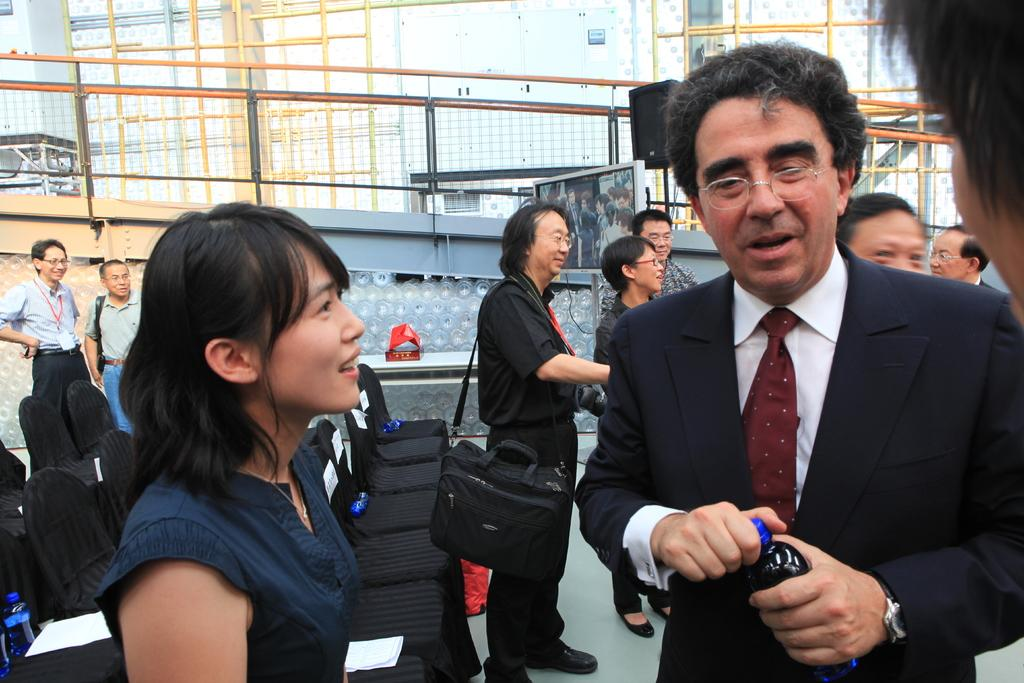Who or what can be seen in the image? There are people in the image. What are the people sitting on in the image? There are chairs in the image. What can be seen in the distance in the image? There are buildings in the background of the image. What objects are present that resemble long, thin bars? There are rods in the image or background. What is the flat, rectangular object in the image? There is a board in the image. What type of grain is being harvested in the image? There is no grain present in the image; it features people, chairs, buildings, rods, and a board. What ornament is hanging from the ceiling in the image? There is no ornament hanging from the ceiling in the image. 